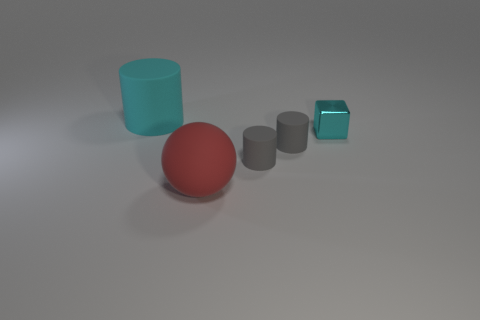What shape is the object behind the cyan shiny object?
Your response must be concise. Cylinder. What is the color of the cylinder that is the same size as the red ball?
Ensure brevity in your answer.  Cyan. There is a tiny cyan metal thing; does it have the same shape as the cyan object that is to the left of the small cyan metal block?
Make the answer very short. No. What material is the large thing that is right of the rubber object on the left side of the big thing in front of the cyan metallic cube?
Your response must be concise. Rubber. What number of small objects are yellow shiny cubes or cyan matte objects?
Give a very brief answer. 0. How many other objects are the same size as the block?
Make the answer very short. 2. Does the cyan thing that is on the right side of the red sphere have the same shape as the big red object?
Give a very brief answer. No. Are there any other things that have the same shape as the cyan rubber object?
Your response must be concise. Yes. Are there an equal number of cyan metallic objects that are behind the cyan rubber cylinder and tiny shiny objects?
Provide a short and direct response. No. How many cyan objects are both in front of the cyan matte object and left of the small cyan shiny block?
Offer a terse response. 0. 